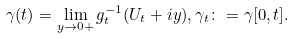Convert formula to latex. <formula><loc_0><loc_0><loc_500><loc_500>\gamma ( t ) = \lim _ { y \to 0 + } g ^ { - 1 } _ { t } ( U _ { t } + i y ) , \gamma _ { t } \colon = \gamma [ 0 , t ] .</formula> 